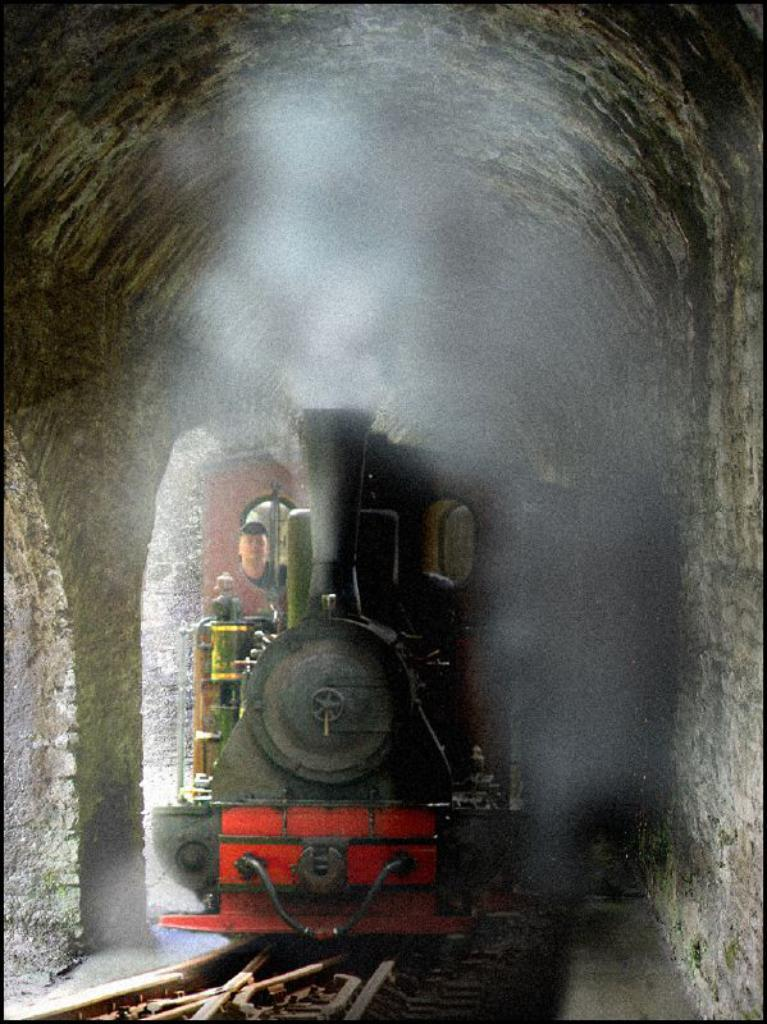Who or what is present in the image? There is a person in the image. What mode of transportation can be seen in the image? There is a train in the image. What is the train traveling on? There is a railway track in the image. What feature is present along the train's path? There is a tunnel in the image. What type of vegetable is being harvested in the image? There is no vegetable or harvesting activity present in the image. What type of battle is taking place in the image? There is no battle or conflict depicted in the image. 